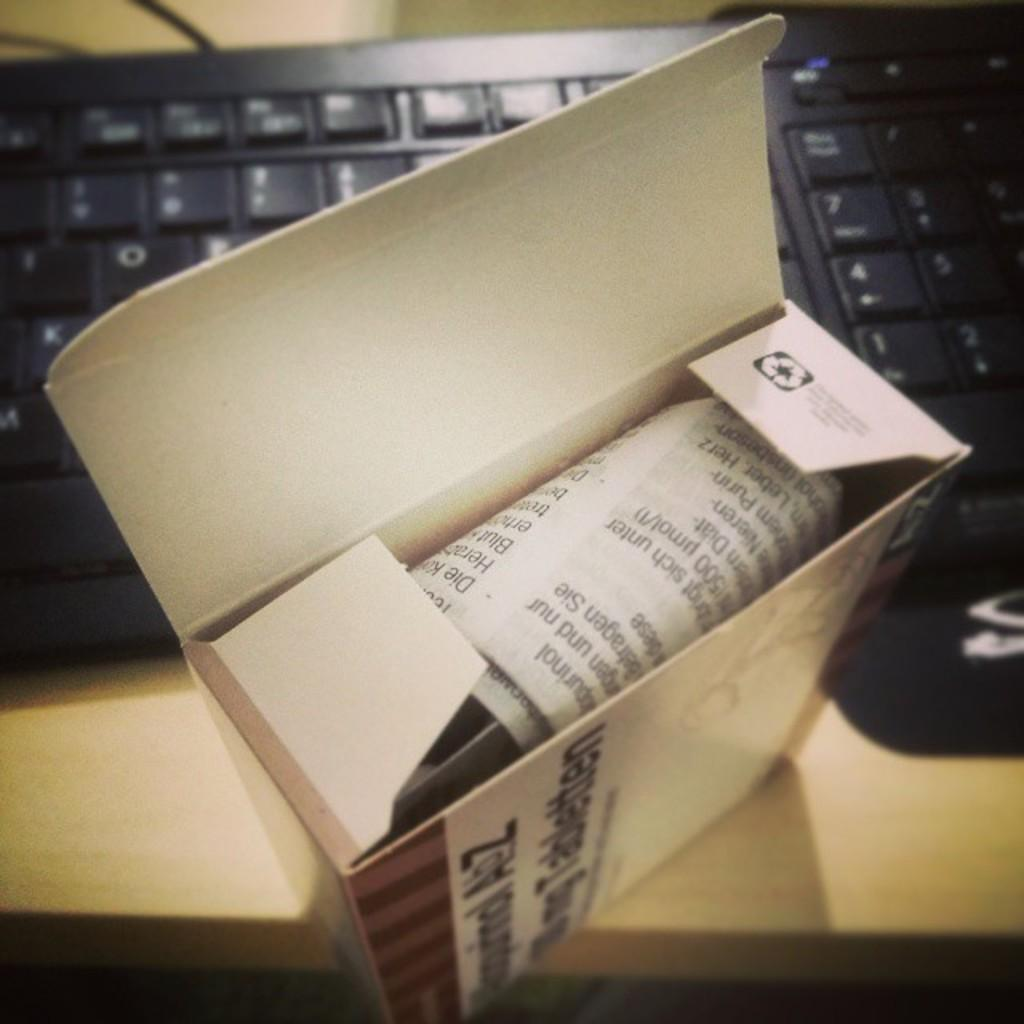<image>
Relay a brief, clear account of the picture shown. the letters A and Z are on the side of a box 